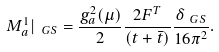Convert formula to latex. <formula><loc_0><loc_0><loc_500><loc_500>M ^ { 1 } _ { a } | _ { \ G S } = \frac { g ^ { 2 } _ { a } ( \mu ) } { 2 } \frac { 2 F ^ { T } } { ( t + \bar { t } ) } \frac { \delta _ { \ G S } } { 1 6 \pi ^ { 2 } } .</formula> 